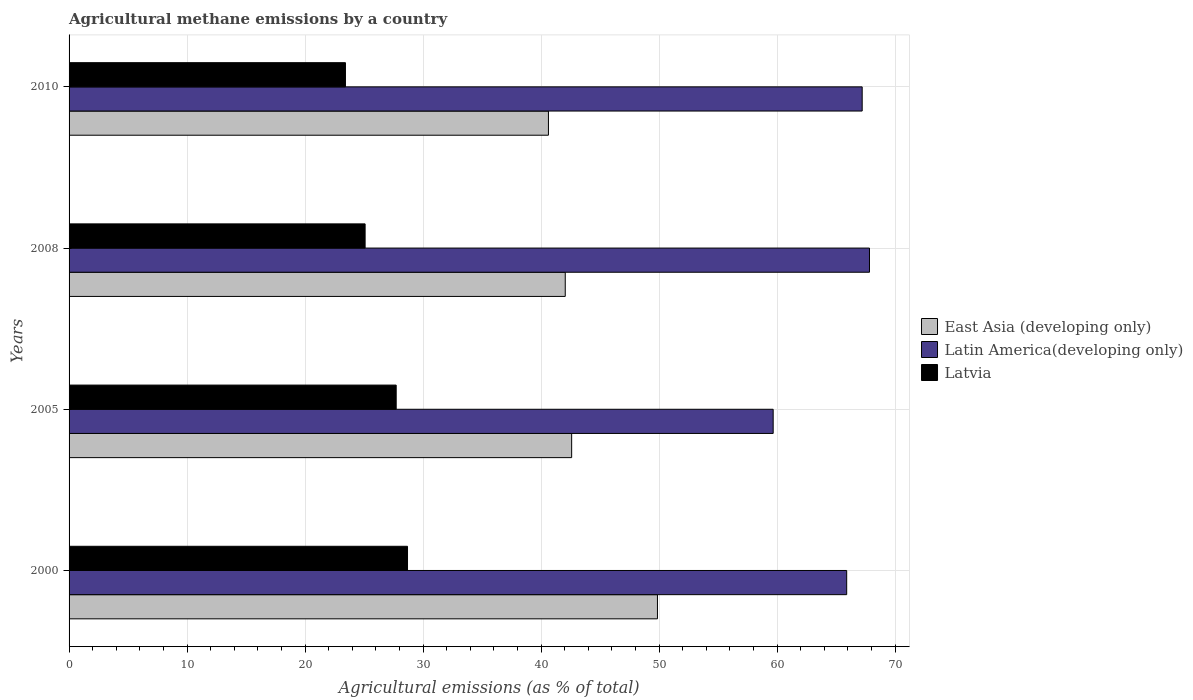How many groups of bars are there?
Provide a short and direct response. 4. How many bars are there on the 2nd tick from the top?
Your answer should be very brief. 3. What is the label of the 1st group of bars from the top?
Ensure brevity in your answer.  2010. What is the amount of agricultural methane emitted in Latvia in 2008?
Offer a terse response. 25.09. Across all years, what is the maximum amount of agricultural methane emitted in East Asia (developing only)?
Keep it short and to the point. 49.86. Across all years, what is the minimum amount of agricultural methane emitted in Latvia?
Keep it short and to the point. 23.42. In which year was the amount of agricultural methane emitted in Latin America(developing only) minimum?
Offer a very short reply. 2005. What is the total amount of agricultural methane emitted in East Asia (developing only) in the graph?
Keep it short and to the point. 175.12. What is the difference between the amount of agricultural methane emitted in Latin America(developing only) in 2005 and that in 2010?
Your response must be concise. -7.54. What is the difference between the amount of agricultural methane emitted in East Asia (developing only) in 2005 and the amount of agricultural methane emitted in Latvia in 2008?
Your answer should be very brief. 17.5. What is the average amount of agricultural methane emitted in Latvia per year?
Give a very brief answer. 26.23. In the year 2000, what is the difference between the amount of agricultural methane emitted in Latvia and amount of agricultural methane emitted in Latin America(developing only)?
Give a very brief answer. -37.22. What is the ratio of the amount of agricultural methane emitted in East Asia (developing only) in 2000 to that in 2008?
Keep it short and to the point. 1.19. Is the difference between the amount of agricultural methane emitted in Latvia in 2000 and 2010 greater than the difference between the amount of agricultural methane emitted in Latin America(developing only) in 2000 and 2010?
Your answer should be compact. Yes. What is the difference between the highest and the second highest amount of agricultural methane emitted in Latvia?
Your answer should be very brief. 0.96. What is the difference between the highest and the lowest amount of agricultural methane emitted in Latin America(developing only)?
Your response must be concise. 8.16. In how many years, is the amount of agricultural methane emitted in Latin America(developing only) greater than the average amount of agricultural methane emitted in Latin America(developing only) taken over all years?
Your answer should be compact. 3. What does the 1st bar from the top in 2000 represents?
Offer a very short reply. Latvia. What does the 1st bar from the bottom in 2010 represents?
Provide a succinct answer. East Asia (developing only). How many bars are there?
Your answer should be very brief. 12. Does the graph contain grids?
Give a very brief answer. Yes. Where does the legend appear in the graph?
Your answer should be compact. Center right. How many legend labels are there?
Give a very brief answer. 3. What is the title of the graph?
Offer a very short reply. Agricultural methane emissions by a country. What is the label or title of the X-axis?
Your answer should be compact. Agricultural emissions (as % of total). What is the Agricultural emissions (as % of total) of East Asia (developing only) in 2000?
Give a very brief answer. 49.86. What is the Agricultural emissions (as % of total) in Latin America(developing only) in 2000?
Keep it short and to the point. 65.9. What is the Agricultural emissions (as % of total) of Latvia in 2000?
Your answer should be compact. 28.68. What is the Agricultural emissions (as % of total) in East Asia (developing only) in 2005?
Your answer should be compact. 42.59. What is the Agricultural emissions (as % of total) in Latin America(developing only) in 2005?
Give a very brief answer. 59.67. What is the Agricultural emissions (as % of total) of Latvia in 2005?
Give a very brief answer. 27.72. What is the Agricultural emissions (as % of total) in East Asia (developing only) in 2008?
Your answer should be very brief. 42.05. What is the Agricultural emissions (as % of total) of Latin America(developing only) in 2008?
Offer a very short reply. 67.83. What is the Agricultural emissions (as % of total) of Latvia in 2008?
Make the answer very short. 25.09. What is the Agricultural emissions (as % of total) in East Asia (developing only) in 2010?
Give a very brief answer. 40.62. What is the Agricultural emissions (as % of total) in Latin America(developing only) in 2010?
Your answer should be very brief. 67.21. What is the Agricultural emissions (as % of total) in Latvia in 2010?
Keep it short and to the point. 23.42. Across all years, what is the maximum Agricultural emissions (as % of total) in East Asia (developing only)?
Provide a short and direct response. 49.86. Across all years, what is the maximum Agricultural emissions (as % of total) in Latin America(developing only)?
Your answer should be compact. 67.83. Across all years, what is the maximum Agricultural emissions (as % of total) in Latvia?
Keep it short and to the point. 28.68. Across all years, what is the minimum Agricultural emissions (as % of total) in East Asia (developing only)?
Offer a terse response. 40.62. Across all years, what is the minimum Agricultural emissions (as % of total) in Latin America(developing only)?
Ensure brevity in your answer.  59.67. Across all years, what is the minimum Agricultural emissions (as % of total) of Latvia?
Keep it short and to the point. 23.42. What is the total Agricultural emissions (as % of total) in East Asia (developing only) in the graph?
Ensure brevity in your answer.  175.12. What is the total Agricultural emissions (as % of total) of Latin America(developing only) in the graph?
Provide a succinct answer. 260.6. What is the total Agricultural emissions (as % of total) in Latvia in the graph?
Provide a short and direct response. 104.91. What is the difference between the Agricultural emissions (as % of total) of East Asia (developing only) in 2000 and that in 2005?
Offer a very short reply. 7.27. What is the difference between the Agricultural emissions (as % of total) in Latin America(developing only) in 2000 and that in 2005?
Your answer should be very brief. 6.23. What is the difference between the Agricultural emissions (as % of total) in Latvia in 2000 and that in 2005?
Make the answer very short. 0.96. What is the difference between the Agricultural emissions (as % of total) in East Asia (developing only) in 2000 and that in 2008?
Give a very brief answer. 7.81. What is the difference between the Agricultural emissions (as % of total) in Latin America(developing only) in 2000 and that in 2008?
Your answer should be compact. -1.93. What is the difference between the Agricultural emissions (as % of total) in Latvia in 2000 and that in 2008?
Provide a succinct answer. 3.59. What is the difference between the Agricultural emissions (as % of total) of East Asia (developing only) in 2000 and that in 2010?
Provide a short and direct response. 9.24. What is the difference between the Agricultural emissions (as % of total) in Latin America(developing only) in 2000 and that in 2010?
Ensure brevity in your answer.  -1.31. What is the difference between the Agricultural emissions (as % of total) of Latvia in 2000 and that in 2010?
Offer a terse response. 5.26. What is the difference between the Agricultural emissions (as % of total) in East Asia (developing only) in 2005 and that in 2008?
Provide a succinct answer. 0.54. What is the difference between the Agricultural emissions (as % of total) in Latin America(developing only) in 2005 and that in 2008?
Keep it short and to the point. -8.16. What is the difference between the Agricultural emissions (as % of total) of Latvia in 2005 and that in 2008?
Give a very brief answer. 2.63. What is the difference between the Agricultural emissions (as % of total) of East Asia (developing only) in 2005 and that in 2010?
Your response must be concise. 1.97. What is the difference between the Agricultural emissions (as % of total) in Latin America(developing only) in 2005 and that in 2010?
Offer a very short reply. -7.54. What is the difference between the Agricultural emissions (as % of total) of Latvia in 2005 and that in 2010?
Offer a very short reply. 4.3. What is the difference between the Agricultural emissions (as % of total) in East Asia (developing only) in 2008 and that in 2010?
Your response must be concise. 1.42. What is the difference between the Agricultural emissions (as % of total) in Latin America(developing only) in 2008 and that in 2010?
Ensure brevity in your answer.  0.62. What is the difference between the Agricultural emissions (as % of total) of Latvia in 2008 and that in 2010?
Offer a very short reply. 1.67. What is the difference between the Agricultural emissions (as % of total) of East Asia (developing only) in 2000 and the Agricultural emissions (as % of total) of Latin America(developing only) in 2005?
Your response must be concise. -9.81. What is the difference between the Agricultural emissions (as % of total) of East Asia (developing only) in 2000 and the Agricultural emissions (as % of total) of Latvia in 2005?
Offer a very short reply. 22.14. What is the difference between the Agricultural emissions (as % of total) of Latin America(developing only) in 2000 and the Agricultural emissions (as % of total) of Latvia in 2005?
Give a very brief answer. 38.18. What is the difference between the Agricultural emissions (as % of total) in East Asia (developing only) in 2000 and the Agricultural emissions (as % of total) in Latin America(developing only) in 2008?
Keep it short and to the point. -17.97. What is the difference between the Agricultural emissions (as % of total) of East Asia (developing only) in 2000 and the Agricultural emissions (as % of total) of Latvia in 2008?
Your answer should be compact. 24.77. What is the difference between the Agricultural emissions (as % of total) of Latin America(developing only) in 2000 and the Agricultural emissions (as % of total) of Latvia in 2008?
Your response must be concise. 40.81. What is the difference between the Agricultural emissions (as % of total) in East Asia (developing only) in 2000 and the Agricultural emissions (as % of total) in Latin America(developing only) in 2010?
Your response must be concise. -17.35. What is the difference between the Agricultural emissions (as % of total) of East Asia (developing only) in 2000 and the Agricultural emissions (as % of total) of Latvia in 2010?
Make the answer very short. 26.44. What is the difference between the Agricultural emissions (as % of total) of Latin America(developing only) in 2000 and the Agricultural emissions (as % of total) of Latvia in 2010?
Provide a short and direct response. 42.47. What is the difference between the Agricultural emissions (as % of total) of East Asia (developing only) in 2005 and the Agricultural emissions (as % of total) of Latin America(developing only) in 2008?
Your answer should be compact. -25.24. What is the difference between the Agricultural emissions (as % of total) in East Asia (developing only) in 2005 and the Agricultural emissions (as % of total) in Latvia in 2008?
Give a very brief answer. 17.5. What is the difference between the Agricultural emissions (as % of total) in Latin America(developing only) in 2005 and the Agricultural emissions (as % of total) in Latvia in 2008?
Your answer should be very brief. 34.58. What is the difference between the Agricultural emissions (as % of total) in East Asia (developing only) in 2005 and the Agricultural emissions (as % of total) in Latin America(developing only) in 2010?
Your answer should be very brief. -24.62. What is the difference between the Agricultural emissions (as % of total) of East Asia (developing only) in 2005 and the Agricultural emissions (as % of total) of Latvia in 2010?
Provide a short and direct response. 19.17. What is the difference between the Agricultural emissions (as % of total) in Latin America(developing only) in 2005 and the Agricultural emissions (as % of total) in Latvia in 2010?
Give a very brief answer. 36.24. What is the difference between the Agricultural emissions (as % of total) in East Asia (developing only) in 2008 and the Agricultural emissions (as % of total) in Latin America(developing only) in 2010?
Your answer should be compact. -25.16. What is the difference between the Agricultural emissions (as % of total) in East Asia (developing only) in 2008 and the Agricultural emissions (as % of total) in Latvia in 2010?
Your answer should be compact. 18.63. What is the difference between the Agricultural emissions (as % of total) of Latin America(developing only) in 2008 and the Agricultural emissions (as % of total) of Latvia in 2010?
Your answer should be compact. 44.41. What is the average Agricultural emissions (as % of total) of East Asia (developing only) per year?
Offer a terse response. 43.78. What is the average Agricultural emissions (as % of total) of Latin America(developing only) per year?
Keep it short and to the point. 65.15. What is the average Agricultural emissions (as % of total) in Latvia per year?
Your answer should be very brief. 26.23. In the year 2000, what is the difference between the Agricultural emissions (as % of total) in East Asia (developing only) and Agricultural emissions (as % of total) in Latin America(developing only)?
Your answer should be very brief. -16.04. In the year 2000, what is the difference between the Agricultural emissions (as % of total) of East Asia (developing only) and Agricultural emissions (as % of total) of Latvia?
Keep it short and to the point. 21.18. In the year 2000, what is the difference between the Agricultural emissions (as % of total) in Latin America(developing only) and Agricultural emissions (as % of total) in Latvia?
Offer a very short reply. 37.22. In the year 2005, what is the difference between the Agricultural emissions (as % of total) in East Asia (developing only) and Agricultural emissions (as % of total) in Latin America(developing only)?
Provide a succinct answer. -17.08. In the year 2005, what is the difference between the Agricultural emissions (as % of total) in East Asia (developing only) and Agricultural emissions (as % of total) in Latvia?
Your answer should be very brief. 14.87. In the year 2005, what is the difference between the Agricultural emissions (as % of total) in Latin America(developing only) and Agricultural emissions (as % of total) in Latvia?
Your answer should be compact. 31.95. In the year 2008, what is the difference between the Agricultural emissions (as % of total) in East Asia (developing only) and Agricultural emissions (as % of total) in Latin America(developing only)?
Make the answer very short. -25.78. In the year 2008, what is the difference between the Agricultural emissions (as % of total) in East Asia (developing only) and Agricultural emissions (as % of total) in Latvia?
Offer a very short reply. 16.96. In the year 2008, what is the difference between the Agricultural emissions (as % of total) of Latin America(developing only) and Agricultural emissions (as % of total) of Latvia?
Your response must be concise. 42.74. In the year 2010, what is the difference between the Agricultural emissions (as % of total) in East Asia (developing only) and Agricultural emissions (as % of total) in Latin America(developing only)?
Give a very brief answer. -26.59. In the year 2010, what is the difference between the Agricultural emissions (as % of total) in East Asia (developing only) and Agricultural emissions (as % of total) in Latvia?
Offer a terse response. 17.2. In the year 2010, what is the difference between the Agricultural emissions (as % of total) of Latin America(developing only) and Agricultural emissions (as % of total) of Latvia?
Keep it short and to the point. 43.79. What is the ratio of the Agricultural emissions (as % of total) of East Asia (developing only) in 2000 to that in 2005?
Ensure brevity in your answer.  1.17. What is the ratio of the Agricultural emissions (as % of total) of Latin America(developing only) in 2000 to that in 2005?
Offer a terse response. 1.1. What is the ratio of the Agricultural emissions (as % of total) of Latvia in 2000 to that in 2005?
Make the answer very short. 1.03. What is the ratio of the Agricultural emissions (as % of total) in East Asia (developing only) in 2000 to that in 2008?
Ensure brevity in your answer.  1.19. What is the ratio of the Agricultural emissions (as % of total) in Latin America(developing only) in 2000 to that in 2008?
Your answer should be very brief. 0.97. What is the ratio of the Agricultural emissions (as % of total) of Latvia in 2000 to that in 2008?
Your answer should be compact. 1.14. What is the ratio of the Agricultural emissions (as % of total) of East Asia (developing only) in 2000 to that in 2010?
Give a very brief answer. 1.23. What is the ratio of the Agricultural emissions (as % of total) of Latin America(developing only) in 2000 to that in 2010?
Ensure brevity in your answer.  0.98. What is the ratio of the Agricultural emissions (as % of total) of Latvia in 2000 to that in 2010?
Keep it short and to the point. 1.22. What is the ratio of the Agricultural emissions (as % of total) in East Asia (developing only) in 2005 to that in 2008?
Give a very brief answer. 1.01. What is the ratio of the Agricultural emissions (as % of total) in Latin America(developing only) in 2005 to that in 2008?
Your answer should be compact. 0.88. What is the ratio of the Agricultural emissions (as % of total) of Latvia in 2005 to that in 2008?
Ensure brevity in your answer.  1.1. What is the ratio of the Agricultural emissions (as % of total) of East Asia (developing only) in 2005 to that in 2010?
Ensure brevity in your answer.  1.05. What is the ratio of the Agricultural emissions (as % of total) in Latin America(developing only) in 2005 to that in 2010?
Offer a very short reply. 0.89. What is the ratio of the Agricultural emissions (as % of total) in Latvia in 2005 to that in 2010?
Your answer should be very brief. 1.18. What is the ratio of the Agricultural emissions (as % of total) in East Asia (developing only) in 2008 to that in 2010?
Provide a succinct answer. 1.04. What is the ratio of the Agricultural emissions (as % of total) in Latin America(developing only) in 2008 to that in 2010?
Ensure brevity in your answer.  1.01. What is the ratio of the Agricultural emissions (as % of total) of Latvia in 2008 to that in 2010?
Offer a terse response. 1.07. What is the difference between the highest and the second highest Agricultural emissions (as % of total) in East Asia (developing only)?
Offer a very short reply. 7.27. What is the difference between the highest and the second highest Agricultural emissions (as % of total) in Latin America(developing only)?
Your response must be concise. 0.62. What is the difference between the highest and the second highest Agricultural emissions (as % of total) of Latvia?
Offer a terse response. 0.96. What is the difference between the highest and the lowest Agricultural emissions (as % of total) of East Asia (developing only)?
Offer a very short reply. 9.24. What is the difference between the highest and the lowest Agricultural emissions (as % of total) of Latin America(developing only)?
Your answer should be compact. 8.16. What is the difference between the highest and the lowest Agricultural emissions (as % of total) in Latvia?
Make the answer very short. 5.26. 